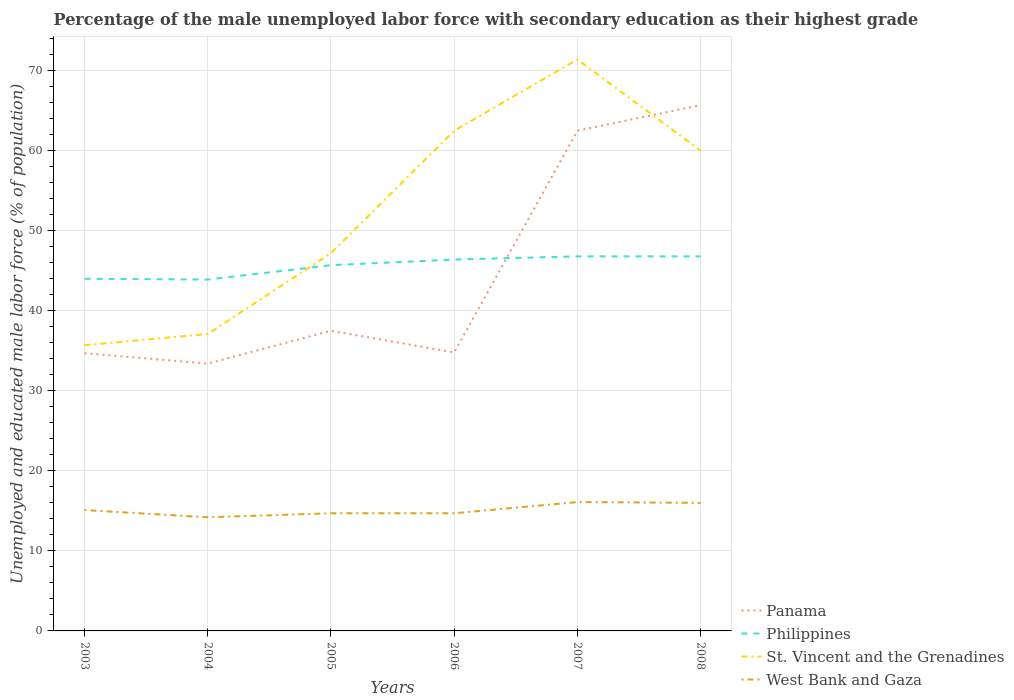Across all years, what is the maximum percentage of the unemployed male labor force with secondary education in West Bank and Gaza?
Keep it short and to the point. 14.2. In which year was the percentage of the unemployed male labor force with secondary education in Philippines maximum?
Offer a terse response. 2004. What is the total percentage of the unemployed male labor force with secondary education in Panama in the graph?
Provide a succinct answer. -29.1. What is the difference between the highest and the second highest percentage of the unemployed male labor force with secondary education in St. Vincent and the Grenadines?
Provide a succinct answer. 35.7. What is the difference between the highest and the lowest percentage of the unemployed male labor force with secondary education in West Bank and Gaza?
Provide a succinct answer. 2. Is the percentage of the unemployed male labor force with secondary education in St. Vincent and the Grenadines strictly greater than the percentage of the unemployed male labor force with secondary education in West Bank and Gaza over the years?
Your answer should be very brief. No. Are the values on the major ticks of Y-axis written in scientific E-notation?
Offer a terse response. No. Does the graph contain any zero values?
Ensure brevity in your answer.  No. Does the graph contain grids?
Your response must be concise. Yes. How many legend labels are there?
Ensure brevity in your answer.  4. How are the legend labels stacked?
Your response must be concise. Vertical. What is the title of the graph?
Offer a terse response. Percentage of the male unemployed labor force with secondary education as their highest grade. Does "Finland" appear as one of the legend labels in the graph?
Give a very brief answer. No. What is the label or title of the Y-axis?
Make the answer very short. Unemployed and educated male labor force (% of population). What is the Unemployed and educated male labor force (% of population) of Panama in 2003?
Your response must be concise. 34.7. What is the Unemployed and educated male labor force (% of population) of Philippines in 2003?
Offer a terse response. 44. What is the Unemployed and educated male labor force (% of population) of St. Vincent and the Grenadines in 2003?
Offer a very short reply. 35.7. What is the Unemployed and educated male labor force (% of population) of West Bank and Gaza in 2003?
Ensure brevity in your answer.  15.1. What is the Unemployed and educated male labor force (% of population) in Panama in 2004?
Make the answer very short. 33.4. What is the Unemployed and educated male labor force (% of population) in Philippines in 2004?
Keep it short and to the point. 43.9. What is the Unemployed and educated male labor force (% of population) of St. Vincent and the Grenadines in 2004?
Offer a terse response. 37.1. What is the Unemployed and educated male labor force (% of population) in West Bank and Gaza in 2004?
Your answer should be compact. 14.2. What is the Unemployed and educated male labor force (% of population) in Panama in 2005?
Keep it short and to the point. 37.5. What is the Unemployed and educated male labor force (% of population) of Philippines in 2005?
Offer a very short reply. 45.7. What is the Unemployed and educated male labor force (% of population) of St. Vincent and the Grenadines in 2005?
Offer a very short reply. 47.2. What is the Unemployed and educated male labor force (% of population) of West Bank and Gaza in 2005?
Your answer should be compact. 14.7. What is the Unemployed and educated male labor force (% of population) in Panama in 2006?
Make the answer very short. 34.8. What is the Unemployed and educated male labor force (% of population) in Philippines in 2006?
Your response must be concise. 46.4. What is the Unemployed and educated male labor force (% of population) of St. Vincent and the Grenadines in 2006?
Your answer should be compact. 62.5. What is the Unemployed and educated male labor force (% of population) in West Bank and Gaza in 2006?
Offer a terse response. 14.7. What is the Unemployed and educated male labor force (% of population) in Panama in 2007?
Keep it short and to the point. 62.5. What is the Unemployed and educated male labor force (% of population) in Philippines in 2007?
Give a very brief answer. 46.8. What is the Unemployed and educated male labor force (% of population) in St. Vincent and the Grenadines in 2007?
Keep it short and to the point. 71.4. What is the Unemployed and educated male labor force (% of population) in West Bank and Gaza in 2007?
Provide a short and direct response. 16.1. What is the Unemployed and educated male labor force (% of population) of Panama in 2008?
Give a very brief answer. 65.7. What is the Unemployed and educated male labor force (% of population) in Philippines in 2008?
Provide a short and direct response. 46.8. What is the Unemployed and educated male labor force (% of population) in St. Vincent and the Grenadines in 2008?
Offer a very short reply. 60. What is the Unemployed and educated male labor force (% of population) of West Bank and Gaza in 2008?
Make the answer very short. 16. Across all years, what is the maximum Unemployed and educated male labor force (% of population) in Panama?
Ensure brevity in your answer.  65.7. Across all years, what is the maximum Unemployed and educated male labor force (% of population) in Philippines?
Ensure brevity in your answer.  46.8. Across all years, what is the maximum Unemployed and educated male labor force (% of population) in St. Vincent and the Grenadines?
Provide a short and direct response. 71.4. Across all years, what is the maximum Unemployed and educated male labor force (% of population) of West Bank and Gaza?
Give a very brief answer. 16.1. Across all years, what is the minimum Unemployed and educated male labor force (% of population) in Panama?
Provide a succinct answer. 33.4. Across all years, what is the minimum Unemployed and educated male labor force (% of population) of Philippines?
Your response must be concise. 43.9. Across all years, what is the minimum Unemployed and educated male labor force (% of population) of St. Vincent and the Grenadines?
Give a very brief answer. 35.7. Across all years, what is the minimum Unemployed and educated male labor force (% of population) in West Bank and Gaza?
Provide a short and direct response. 14.2. What is the total Unemployed and educated male labor force (% of population) of Panama in the graph?
Make the answer very short. 268.6. What is the total Unemployed and educated male labor force (% of population) of Philippines in the graph?
Ensure brevity in your answer.  273.6. What is the total Unemployed and educated male labor force (% of population) of St. Vincent and the Grenadines in the graph?
Ensure brevity in your answer.  313.9. What is the total Unemployed and educated male labor force (% of population) of West Bank and Gaza in the graph?
Your answer should be very brief. 90.8. What is the difference between the Unemployed and educated male labor force (% of population) of Philippines in 2003 and that in 2004?
Ensure brevity in your answer.  0.1. What is the difference between the Unemployed and educated male labor force (% of population) of West Bank and Gaza in 2003 and that in 2004?
Provide a succinct answer. 0.9. What is the difference between the Unemployed and educated male labor force (% of population) in West Bank and Gaza in 2003 and that in 2005?
Your response must be concise. 0.4. What is the difference between the Unemployed and educated male labor force (% of population) of Panama in 2003 and that in 2006?
Keep it short and to the point. -0.1. What is the difference between the Unemployed and educated male labor force (% of population) in Philippines in 2003 and that in 2006?
Ensure brevity in your answer.  -2.4. What is the difference between the Unemployed and educated male labor force (% of population) of St. Vincent and the Grenadines in 2003 and that in 2006?
Your response must be concise. -26.8. What is the difference between the Unemployed and educated male labor force (% of population) of West Bank and Gaza in 2003 and that in 2006?
Ensure brevity in your answer.  0.4. What is the difference between the Unemployed and educated male labor force (% of population) of Panama in 2003 and that in 2007?
Make the answer very short. -27.8. What is the difference between the Unemployed and educated male labor force (% of population) in Philippines in 2003 and that in 2007?
Your answer should be compact. -2.8. What is the difference between the Unemployed and educated male labor force (% of population) in St. Vincent and the Grenadines in 2003 and that in 2007?
Your answer should be compact. -35.7. What is the difference between the Unemployed and educated male labor force (% of population) in Panama in 2003 and that in 2008?
Ensure brevity in your answer.  -31. What is the difference between the Unemployed and educated male labor force (% of population) in Philippines in 2003 and that in 2008?
Ensure brevity in your answer.  -2.8. What is the difference between the Unemployed and educated male labor force (% of population) of St. Vincent and the Grenadines in 2003 and that in 2008?
Give a very brief answer. -24.3. What is the difference between the Unemployed and educated male labor force (% of population) of West Bank and Gaza in 2003 and that in 2008?
Give a very brief answer. -0.9. What is the difference between the Unemployed and educated male labor force (% of population) in St. Vincent and the Grenadines in 2004 and that in 2005?
Provide a succinct answer. -10.1. What is the difference between the Unemployed and educated male labor force (% of population) in Panama in 2004 and that in 2006?
Offer a terse response. -1.4. What is the difference between the Unemployed and educated male labor force (% of population) in Philippines in 2004 and that in 2006?
Offer a very short reply. -2.5. What is the difference between the Unemployed and educated male labor force (% of population) of St. Vincent and the Grenadines in 2004 and that in 2006?
Provide a succinct answer. -25.4. What is the difference between the Unemployed and educated male labor force (% of population) in Panama in 2004 and that in 2007?
Your response must be concise. -29.1. What is the difference between the Unemployed and educated male labor force (% of population) of Philippines in 2004 and that in 2007?
Keep it short and to the point. -2.9. What is the difference between the Unemployed and educated male labor force (% of population) in St. Vincent and the Grenadines in 2004 and that in 2007?
Offer a very short reply. -34.3. What is the difference between the Unemployed and educated male labor force (% of population) in West Bank and Gaza in 2004 and that in 2007?
Provide a succinct answer. -1.9. What is the difference between the Unemployed and educated male labor force (% of population) in Panama in 2004 and that in 2008?
Your answer should be compact. -32.3. What is the difference between the Unemployed and educated male labor force (% of population) of Philippines in 2004 and that in 2008?
Keep it short and to the point. -2.9. What is the difference between the Unemployed and educated male labor force (% of population) in St. Vincent and the Grenadines in 2004 and that in 2008?
Your response must be concise. -22.9. What is the difference between the Unemployed and educated male labor force (% of population) in St. Vincent and the Grenadines in 2005 and that in 2006?
Your answer should be very brief. -15.3. What is the difference between the Unemployed and educated male labor force (% of population) in St. Vincent and the Grenadines in 2005 and that in 2007?
Make the answer very short. -24.2. What is the difference between the Unemployed and educated male labor force (% of population) of Panama in 2005 and that in 2008?
Give a very brief answer. -28.2. What is the difference between the Unemployed and educated male labor force (% of population) of Philippines in 2005 and that in 2008?
Keep it short and to the point. -1.1. What is the difference between the Unemployed and educated male labor force (% of population) in St. Vincent and the Grenadines in 2005 and that in 2008?
Offer a terse response. -12.8. What is the difference between the Unemployed and educated male labor force (% of population) of West Bank and Gaza in 2005 and that in 2008?
Keep it short and to the point. -1.3. What is the difference between the Unemployed and educated male labor force (% of population) in Panama in 2006 and that in 2007?
Offer a terse response. -27.7. What is the difference between the Unemployed and educated male labor force (% of population) of Philippines in 2006 and that in 2007?
Ensure brevity in your answer.  -0.4. What is the difference between the Unemployed and educated male labor force (% of population) in West Bank and Gaza in 2006 and that in 2007?
Give a very brief answer. -1.4. What is the difference between the Unemployed and educated male labor force (% of population) in Panama in 2006 and that in 2008?
Your response must be concise. -30.9. What is the difference between the Unemployed and educated male labor force (% of population) of Philippines in 2006 and that in 2008?
Make the answer very short. -0.4. What is the difference between the Unemployed and educated male labor force (% of population) of West Bank and Gaza in 2006 and that in 2008?
Give a very brief answer. -1.3. What is the difference between the Unemployed and educated male labor force (% of population) of Philippines in 2007 and that in 2008?
Keep it short and to the point. 0. What is the difference between the Unemployed and educated male labor force (% of population) in St. Vincent and the Grenadines in 2007 and that in 2008?
Provide a short and direct response. 11.4. What is the difference between the Unemployed and educated male labor force (% of population) of Panama in 2003 and the Unemployed and educated male labor force (% of population) of St. Vincent and the Grenadines in 2004?
Your response must be concise. -2.4. What is the difference between the Unemployed and educated male labor force (% of population) in Panama in 2003 and the Unemployed and educated male labor force (% of population) in West Bank and Gaza in 2004?
Ensure brevity in your answer.  20.5. What is the difference between the Unemployed and educated male labor force (% of population) in Philippines in 2003 and the Unemployed and educated male labor force (% of population) in St. Vincent and the Grenadines in 2004?
Make the answer very short. 6.9. What is the difference between the Unemployed and educated male labor force (% of population) in Philippines in 2003 and the Unemployed and educated male labor force (% of population) in West Bank and Gaza in 2004?
Offer a very short reply. 29.8. What is the difference between the Unemployed and educated male labor force (% of population) of St. Vincent and the Grenadines in 2003 and the Unemployed and educated male labor force (% of population) of West Bank and Gaza in 2004?
Ensure brevity in your answer.  21.5. What is the difference between the Unemployed and educated male labor force (% of population) of Panama in 2003 and the Unemployed and educated male labor force (% of population) of Philippines in 2005?
Offer a terse response. -11. What is the difference between the Unemployed and educated male labor force (% of population) in Philippines in 2003 and the Unemployed and educated male labor force (% of population) in St. Vincent and the Grenadines in 2005?
Keep it short and to the point. -3.2. What is the difference between the Unemployed and educated male labor force (% of population) in Philippines in 2003 and the Unemployed and educated male labor force (% of population) in West Bank and Gaza in 2005?
Offer a terse response. 29.3. What is the difference between the Unemployed and educated male labor force (% of population) in Panama in 2003 and the Unemployed and educated male labor force (% of population) in Philippines in 2006?
Provide a short and direct response. -11.7. What is the difference between the Unemployed and educated male labor force (% of population) in Panama in 2003 and the Unemployed and educated male labor force (% of population) in St. Vincent and the Grenadines in 2006?
Your answer should be compact. -27.8. What is the difference between the Unemployed and educated male labor force (% of population) of Panama in 2003 and the Unemployed and educated male labor force (% of population) of West Bank and Gaza in 2006?
Keep it short and to the point. 20. What is the difference between the Unemployed and educated male labor force (% of population) in Philippines in 2003 and the Unemployed and educated male labor force (% of population) in St. Vincent and the Grenadines in 2006?
Provide a succinct answer. -18.5. What is the difference between the Unemployed and educated male labor force (% of population) of Philippines in 2003 and the Unemployed and educated male labor force (% of population) of West Bank and Gaza in 2006?
Your response must be concise. 29.3. What is the difference between the Unemployed and educated male labor force (% of population) in Panama in 2003 and the Unemployed and educated male labor force (% of population) in St. Vincent and the Grenadines in 2007?
Make the answer very short. -36.7. What is the difference between the Unemployed and educated male labor force (% of population) of Philippines in 2003 and the Unemployed and educated male labor force (% of population) of St. Vincent and the Grenadines in 2007?
Your response must be concise. -27.4. What is the difference between the Unemployed and educated male labor force (% of population) in Philippines in 2003 and the Unemployed and educated male labor force (% of population) in West Bank and Gaza in 2007?
Keep it short and to the point. 27.9. What is the difference between the Unemployed and educated male labor force (% of population) of St. Vincent and the Grenadines in 2003 and the Unemployed and educated male labor force (% of population) of West Bank and Gaza in 2007?
Your answer should be compact. 19.6. What is the difference between the Unemployed and educated male labor force (% of population) of Panama in 2003 and the Unemployed and educated male labor force (% of population) of St. Vincent and the Grenadines in 2008?
Give a very brief answer. -25.3. What is the difference between the Unemployed and educated male labor force (% of population) in Philippines in 2003 and the Unemployed and educated male labor force (% of population) in West Bank and Gaza in 2008?
Ensure brevity in your answer.  28. What is the difference between the Unemployed and educated male labor force (% of population) of Panama in 2004 and the Unemployed and educated male labor force (% of population) of St. Vincent and the Grenadines in 2005?
Offer a terse response. -13.8. What is the difference between the Unemployed and educated male labor force (% of population) of Panama in 2004 and the Unemployed and educated male labor force (% of population) of West Bank and Gaza in 2005?
Give a very brief answer. 18.7. What is the difference between the Unemployed and educated male labor force (% of population) of Philippines in 2004 and the Unemployed and educated male labor force (% of population) of St. Vincent and the Grenadines in 2005?
Offer a terse response. -3.3. What is the difference between the Unemployed and educated male labor force (% of population) in Philippines in 2004 and the Unemployed and educated male labor force (% of population) in West Bank and Gaza in 2005?
Provide a succinct answer. 29.2. What is the difference between the Unemployed and educated male labor force (% of population) of St. Vincent and the Grenadines in 2004 and the Unemployed and educated male labor force (% of population) of West Bank and Gaza in 2005?
Ensure brevity in your answer.  22.4. What is the difference between the Unemployed and educated male labor force (% of population) in Panama in 2004 and the Unemployed and educated male labor force (% of population) in St. Vincent and the Grenadines in 2006?
Ensure brevity in your answer.  -29.1. What is the difference between the Unemployed and educated male labor force (% of population) of Philippines in 2004 and the Unemployed and educated male labor force (% of population) of St. Vincent and the Grenadines in 2006?
Give a very brief answer. -18.6. What is the difference between the Unemployed and educated male labor force (% of population) in Philippines in 2004 and the Unemployed and educated male labor force (% of population) in West Bank and Gaza in 2006?
Keep it short and to the point. 29.2. What is the difference between the Unemployed and educated male labor force (% of population) of St. Vincent and the Grenadines in 2004 and the Unemployed and educated male labor force (% of population) of West Bank and Gaza in 2006?
Give a very brief answer. 22.4. What is the difference between the Unemployed and educated male labor force (% of population) of Panama in 2004 and the Unemployed and educated male labor force (% of population) of Philippines in 2007?
Provide a short and direct response. -13.4. What is the difference between the Unemployed and educated male labor force (% of population) of Panama in 2004 and the Unemployed and educated male labor force (% of population) of St. Vincent and the Grenadines in 2007?
Offer a terse response. -38. What is the difference between the Unemployed and educated male labor force (% of population) of Panama in 2004 and the Unemployed and educated male labor force (% of population) of West Bank and Gaza in 2007?
Offer a very short reply. 17.3. What is the difference between the Unemployed and educated male labor force (% of population) in Philippines in 2004 and the Unemployed and educated male labor force (% of population) in St. Vincent and the Grenadines in 2007?
Offer a terse response. -27.5. What is the difference between the Unemployed and educated male labor force (% of population) of Philippines in 2004 and the Unemployed and educated male labor force (% of population) of West Bank and Gaza in 2007?
Make the answer very short. 27.8. What is the difference between the Unemployed and educated male labor force (% of population) of Panama in 2004 and the Unemployed and educated male labor force (% of population) of St. Vincent and the Grenadines in 2008?
Your answer should be compact. -26.6. What is the difference between the Unemployed and educated male labor force (% of population) in Panama in 2004 and the Unemployed and educated male labor force (% of population) in West Bank and Gaza in 2008?
Provide a short and direct response. 17.4. What is the difference between the Unemployed and educated male labor force (% of population) of Philippines in 2004 and the Unemployed and educated male labor force (% of population) of St. Vincent and the Grenadines in 2008?
Offer a very short reply. -16.1. What is the difference between the Unemployed and educated male labor force (% of population) of Philippines in 2004 and the Unemployed and educated male labor force (% of population) of West Bank and Gaza in 2008?
Your answer should be very brief. 27.9. What is the difference between the Unemployed and educated male labor force (% of population) in St. Vincent and the Grenadines in 2004 and the Unemployed and educated male labor force (% of population) in West Bank and Gaza in 2008?
Offer a terse response. 21.1. What is the difference between the Unemployed and educated male labor force (% of population) of Panama in 2005 and the Unemployed and educated male labor force (% of population) of Philippines in 2006?
Keep it short and to the point. -8.9. What is the difference between the Unemployed and educated male labor force (% of population) in Panama in 2005 and the Unemployed and educated male labor force (% of population) in St. Vincent and the Grenadines in 2006?
Your answer should be very brief. -25. What is the difference between the Unemployed and educated male labor force (% of population) of Panama in 2005 and the Unemployed and educated male labor force (% of population) of West Bank and Gaza in 2006?
Offer a very short reply. 22.8. What is the difference between the Unemployed and educated male labor force (% of population) of Philippines in 2005 and the Unemployed and educated male labor force (% of population) of St. Vincent and the Grenadines in 2006?
Offer a terse response. -16.8. What is the difference between the Unemployed and educated male labor force (% of population) of St. Vincent and the Grenadines in 2005 and the Unemployed and educated male labor force (% of population) of West Bank and Gaza in 2006?
Provide a succinct answer. 32.5. What is the difference between the Unemployed and educated male labor force (% of population) in Panama in 2005 and the Unemployed and educated male labor force (% of population) in St. Vincent and the Grenadines in 2007?
Offer a terse response. -33.9. What is the difference between the Unemployed and educated male labor force (% of population) in Panama in 2005 and the Unemployed and educated male labor force (% of population) in West Bank and Gaza in 2007?
Keep it short and to the point. 21.4. What is the difference between the Unemployed and educated male labor force (% of population) in Philippines in 2005 and the Unemployed and educated male labor force (% of population) in St. Vincent and the Grenadines in 2007?
Ensure brevity in your answer.  -25.7. What is the difference between the Unemployed and educated male labor force (% of population) in Philippines in 2005 and the Unemployed and educated male labor force (% of population) in West Bank and Gaza in 2007?
Your answer should be very brief. 29.6. What is the difference between the Unemployed and educated male labor force (% of population) in St. Vincent and the Grenadines in 2005 and the Unemployed and educated male labor force (% of population) in West Bank and Gaza in 2007?
Make the answer very short. 31.1. What is the difference between the Unemployed and educated male labor force (% of population) of Panama in 2005 and the Unemployed and educated male labor force (% of population) of St. Vincent and the Grenadines in 2008?
Offer a terse response. -22.5. What is the difference between the Unemployed and educated male labor force (% of population) in Philippines in 2005 and the Unemployed and educated male labor force (% of population) in St. Vincent and the Grenadines in 2008?
Offer a very short reply. -14.3. What is the difference between the Unemployed and educated male labor force (% of population) of Philippines in 2005 and the Unemployed and educated male labor force (% of population) of West Bank and Gaza in 2008?
Keep it short and to the point. 29.7. What is the difference between the Unemployed and educated male labor force (% of population) in St. Vincent and the Grenadines in 2005 and the Unemployed and educated male labor force (% of population) in West Bank and Gaza in 2008?
Keep it short and to the point. 31.2. What is the difference between the Unemployed and educated male labor force (% of population) of Panama in 2006 and the Unemployed and educated male labor force (% of population) of Philippines in 2007?
Make the answer very short. -12. What is the difference between the Unemployed and educated male labor force (% of population) of Panama in 2006 and the Unemployed and educated male labor force (% of population) of St. Vincent and the Grenadines in 2007?
Ensure brevity in your answer.  -36.6. What is the difference between the Unemployed and educated male labor force (% of population) of Panama in 2006 and the Unemployed and educated male labor force (% of population) of West Bank and Gaza in 2007?
Make the answer very short. 18.7. What is the difference between the Unemployed and educated male labor force (% of population) of Philippines in 2006 and the Unemployed and educated male labor force (% of population) of West Bank and Gaza in 2007?
Ensure brevity in your answer.  30.3. What is the difference between the Unemployed and educated male labor force (% of population) in St. Vincent and the Grenadines in 2006 and the Unemployed and educated male labor force (% of population) in West Bank and Gaza in 2007?
Keep it short and to the point. 46.4. What is the difference between the Unemployed and educated male labor force (% of population) of Panama in 2006 and the Unemployed and educated male labor force (% of population) of St. Vincent and the Grenadines in 2008?
Provide a succinct answer. -25.2. What is the difference between the Unemployed and educated male labor force (% of population) of Philippines in 2006 and the Unemployed and educated male labor force (% of population) of West Bank and Gaza in 2008?
Keep it short and to the point. 30.4. What is the difference between the Unemployed and educated male labor force (% of population) of St. Vincent and the Grenadines in 2006 and the Unemployed and educated male labor force (% of population) of West Bank and Gaza in 2008?
Your response must be concise. 46.5. What is the difference between the Unemployed and educated male labor force (% of population) of Panama in 2007 and the Unemployed and educated male labor force (% of population) of Philippines in 2008?
Offer a terse response. 15.7. What is the difference between the Unemployed and educated male labor force (% of population) of Panama in 2007 and the Unemployed and educated male labor force (% of population) of West Bank and Gaza in 2008?
Ensure brevity in your answer.  46.5. What is the difference between the Unemployed and educated male labor force (% of population) in Philippines in 2007 and the Unemployed and educated male labor force (% of population) in West Bank and Gaza in 2008?
Offer a terse response. 30.8. What is the difference between the Unemployed and educated male labor force (% of population) in St. Vincent and the Grenadines in 2007 and the Unemployed and educated male labor force (% of population) in West Bank and Gaza in 2008?
Your answer should be very brief. 55.4. What is the average Unemployed and educated male labor force (% of population) of Panama per year?
Provide a succinct answer. 44.77. What is the average Unemployed and educated male labor force (% of population) in Philippines per year?
Your answer should be very brief. 45.6. What is the average Unemployed and educated male labor force (% of population) in St. Vincent and the Grenadines per year?
Make the answer very short. 52.32. What is the average Unemployed and educated male labor force (% of population) in West Bank and Gaza per year?
Your answer should be very brief. 15.13. In the year 2003, what is the difference between the Unemployed and educated male labor force (% of population) in Panama and Unemployed and educated male labor force (% of population) in West Bank and Gaza?
Offer a very short reply. 19.6. In the year 2003, what is the difference between the Unemployed and educated male labor force (% of population) in Philippines and Unemployed and educated male labor force (% of population) in West Bank and Gaza?
Your answer should be very brief. 28.9. In the year 2003, what is the difference between the Unemployed and educated male labor force (% of population) of St. Vincent and the Grenadines and Unemployed and educated male labor force (% of population) of West Bank and Gaza?
Offer a very short reply. 20.6. In the year 2004, what is the difference between the Unemployed and educated male labor force (% of population) of Panama and Unemployed and educated male labor force (% of population) of Philippines?
Offer a very short reply. -10.5. In the year 2004, what is the difference between the Unemployed and educated male labor force (% of population) in Panama and Unemployed and educated male labor force (% of population) in St. Vincent and the Grenadines?
Ensure brevity in your answer.  -3.7. In the year 2004, what is the difference between the Unemployed and educated male labor force (% of population) of Philippines and Unemployed and educated male labor force (% of population) of St. Vincent and the Grenadines?
Provide a succinct answer. 6.8. In the year 2004, what is the difference between the Unemployed and educated male labor force (% of population) of Philippines and Unemployed and educated male labor force (% of population) of West Bank and Gaza?
Offer a very short reply. 29.7. In the year 2004, what is the difference between the Unemployed and educated male labor force (% of population) in St. Vincent and the Grenadines and Unemployed and educated male labor force (% of population) in West Bank and Gaza?
Give a very brief answer. 22.9. In the year 2005, what is the difference between the Unemployed and educated male labor force (% of population) of Panama and Unemployed and educated male labor force (% of population) of Philippines?
Your answer should be very brief. -8.2. In the year 2005, what is the difference between the Unemployed and educated male labor force (% of population) in Panama and Unemployed and educated male labor force (% of population) in St. Vincent and the Grenadines?
Make the answer very short. -9.7. In the year 2005, what is the difference between the Unemployed and educated male labor force (% of population) of Panama and Unemployed and educated male labor force (% of population) of West Bank and Gaza?
Offer a terse response. 22.8. In the year 2005, what is the difference between the Unemployed and educated male labor force (% of population) of St. Vincent and the Grenadines and Unemployed and educated male labor force (% of population) of West Bank and Gaza?
Offer a very short reply. 32.5. In the year 2006, what is the difference between the Unemployed and educated male labor force (% of population) of Panama and Unemployed and educated male labor force (% of population) of St. Vincent and the Grenadines?
Ensure brevity in your answer.  -27.7. In the year 2006, what is the difference between the Unemployed and educated male labor force (% of population) of Panama and Unemployed and educated male labor force (% of population) of West Bank and Gaza?
Provide a succinct answer. 20.1. In the year 2006, what is the difference between the Unemployed and educated male labor force (% of population) of Philippines and Unemployed and educated male labor force (% of population) of St. Vincent and the Grenadines?
Your answer should be very brief. -16.1. In the year 2006, what is the difference between the Unemployed and educated male labor force (% of population) of Philippines and Unemployed and educated male labor force (% of population) of West Bank and Gaza?
Provide a succinct answer. 31.7. In the year 2006, what is the difference between the Unemployed and educated male labor force (% of population) in St. Vincent and the Grenadines and Unemployed and educated male labor force (% of population) in West Bank and Gaza?
Your response must be concise. 47.8. In the year 2007, what is the difference between the Unemployed and educated male labor force (% of population) in Panama and Unemployed and educated male labor force (% of population) in Philippines?
Your response must be concise. 15.7. In the year 2007, what is the difference between the Unemployed and educated male labor force (% of population) of Panama and Unemployed and educated male labor force (% of population) of West Bank and Gaza?
Make the answer very short. 46.4. In the year 2007, what is the difference between the Unemployed and educated male labor force (% of population) in Philippines and Unemployed and educated male labor force (% of population) in St. Vincent and the Grenadines?
Your answer should be very brief. -24.6. In the year 2007, what is the difference between the Unemployed and educated male labor force (% of population) in Philippines and Unemployed and educated male labor force (% of population) in West Bank and Gaza?
Offer a very short reply. 30.7. In the year 2007, what is the difference between the Unemployed and educated male labor force (% of population) in St. Vincent and the Grenadines and Unemployed and educated male labor force (% of population) in West Bank and Gaza?
Provide a short and direct response. 55.3. In the year 2008, what is the difference between the Unemployed and educated male labor force (% of population) in Panama and Unemployed and educated male labor force (% of population) in Philippines?
Provide a short and direct response. 18.9. In the year 2008, what is the difference between the Unemployed and educated male labor force (% of population) of Panama and Unemployed and educated male labor force (% of population) of West Bank and Gaza?
Your answer should be very brief. 49.7. In the year 2008, what is the difference between the Unemployed and educated male labor force (% of population) of Philippines and Unemployed and educated male labor force (% of population) of West Bank and Gaza?
Your answer should be compact. 30.8. What is the ratio of the Unemployed and educated male labor force (% of population) in Panama in 2003 to that in 2004?
Keep it short and to the point. 1.04. What is the ratio of the Unemployed and educated male labor force (% of population) in Philippines in 2003 to that in 2004?
Offer a very short reply. 1. What is the ratio of the Unemployed and educated male labor force (% of population) in St. Vincent and the Grenadines in 2003 to that in 2004?
Offer a very short reply. 0.96. What is the ratio of the Unemployed and educated male labor force (% of population) in West Bank and Gaza in 2003 to that in 2004?
Ensure brevity in your answer.  1.06. What is the ratio of the Unemployed and educated male labor force (% of population) of Panama in 2003 to that in 2005?
Ensure brevity in your answer.  0.93. What is the ratio of the Unemployed and educated male labor force (% of population) in Philippines in 2003 to that in 2005?
Ensure brevity in your answer.  0.96. What is the ratio of the Unemployed and educated male labor force (% of population) in St. Vincent and the Grenadines in 2003 to that in 2005?
Provide a succinct answer. 0.76. What is the ratio of the Unemployed and educated male labor force (% of population) in West Bank and Gaza in 2003 to that in 2005?
Provide a short and direct response. 1.03. What is the ratio of the Unemployed and educated male labor force (% of population) of Philippines in 2003 to that in 2006?
Offer a terse response. 0.95. What is the ratio of the Unemployed and educated male labor force (% of population) of St. Vincent and the Grenadines in 2003 to that in 2006?
Offer a terse response. 0.57. What is the ratio of the Unemployed and educated male labor force (% of population) of West Bank and Gaza in 2003 to that in 2006?
Your response must be concise. 1.03. What is the ratio of the Unemployed and educated male labor force (% of population) in Panama in 2003 to that in 2007?
Keep it short and to the point. 0.56. What is the ratio of the Unemployed and educated male labor force (% of population) of Philippines in 2003 to that in 2007?
Give a very brief answer. 0.94. What is the ratio of the Unemployed and educated male labor force (% of population) of St. Vincent and the Grenadines in 2003 to that in 2007?
Provide a succinct answer. 0.5. What is the ratio of the Unemployed and educated male labor force (% of population) of West Bank and Gaza in 2003 to that in 2007?
Make the answer very short. 0.94. What is the ratio of the Unemployed and educated male labor force (% of population) in Panama in 2003 to that in 2008?
Offer a very short reply. 0.53. What is the ratio of the Unemployed and educated male labor force (% of population) in Philippines in 2003 to that in 2008?
Give a very brief answer. 0.94. What is the ratio of the Unemployed and educated male labor force (% of population) of St. Vincent and the Grenadines in 2003 to that in 2008?
Provide a succinct answer. 0.59. What is the ratio of the Unemployed and educated male labor force (% of population) of West Bank and Gaza in 2003 to that in 2008?
Your answer should be compact. 0.94. What is the ratio of the Unemployed and educated male labor force (% of population) in Panama in 2004 to that in 2005?
Offer a terse response. 0.89. What is the ratio of the Unemployed and educated male labor force (% of population) in Philippines in 2004 to that in 2005?
Give a very brief answer. 0.96. What is the ratio of the Unemployed and educated male labor force (% of population) of St. Vincent and the Grenadines in 2004 to that in 2005?
Offer a terse response. 0.79. What is the ratio of the Unemployed and educated male labor force (% of population) of West Bank and Gaza in 2004 to that in 2005?
Ensure brevity in your answer.  0.97. What is the ratio of the Unemployed and educated male labor force (% of population) of Panama in 2004 to that in 2006?
Your answer should be very brief. 0.96. What is the ratio of the Unemployed and educated male labor force (% of population) of Philippines in 2004 to that in 2006?
Provide a short and direct response. 0.95. What is the ratio of the Unemployed and educated male labor force (% of population) in St. Vincent and the Grenadines in 2004 to that in 2006?
Provide a short and direct response. 0.59. What is the ratio of the Unemployed and educated male labor force (% of population) in West Bank and Gaza in 2004 to that in 2006?
Keep it short and to the point. 0.97. What is the ratio of the Unemployed and educated male labor force (% of population) of Panama in 2004 to that in 2007?
Ensure brevity in your answer.  0.53. What is the ratio of the Unemployed and educated male labor force (% of population) in Philippines in 2004 to that in 2007?
Your response must be concise. 0.94. What is the ratio of the Unemployed and educated male labor force (% of population) in St. Vincent and the Grenadines in 2004 to that in 2007?
Your answer should be compact. 0.52. What is the ratio of the Unemployed and educated male labor force (% of population) of West Bank and Gaza in 2004 to that in 2007?
Offer a terse response. 0.88. What is the ratio of the Unemployed and educated male labor force (% of population) of Panama in 2004 to that in 2008?
Provide a succinct answer. 0.51. What is the ratio of the Unemployed and educated male labor force (% of population) in Philippines in 2004 to that in 2008?
Your answer should be compact. 0.94. What is the ratio of the Unemployed and educated male labor force (% of population) of St. Vincent and the Grenadines in 2004 to that in 2008?
Your answer should be compact. 0.62. What is the ratio of the Unemployed and educated male labor force (% of population) of West Bank and Gaza in 2004 to that in 2008?
Keep it short and to the point. 0.89. What is the ratio of the Unemployed and educated male labor force (% of population) in Panama in 2005 to that in 2006?
Your answer should be very brief. 1.08. What is the ratio of the Unemployed and educated male labor force (% of population) in Philippines in 2005 to that in 2006?
Make the answer very short. 0.98. What is the ratio of the Unemployed and educated male labor force (% of population) of St. Vincent and the Grenadines in 2005 to that in 2006?
Keep it short and to the point. 0.76. What is the ratio of the Unemployed and educated male labor force (% of population) of Philippines in 2005 to that in 2007?
Offer a terse response. 0.98. What is the ratio of the Unemployed and educated male labor force (% of population) of St. Vincent and the Grenadines in 2005 to that in 2007?
Ensure brevity in your answer.  0.66. What is the ratio of the Unemployed and educated male labor force (% of population) in Panama in 2005 to that in 2008?
Provide a short and direct response. 0.57. What is the ratio of the Unemployed and educated male labor force (% of population) of Philippines in 2005 to that in 2008?
Your answer should be compact. 0.98. What is the ratio of the Unemployed and educated male labor force (% of population) of St. Vincent and the Grenadines in 2005 to that in 2008?
Ensure brevity in your answer.  0.79. What is the ratio of the Unemployed and educated male labor force (% of population) in West Bank and Gaza in 2005 to that in 2008?
Provide a succinct answer. 0.92. What is the ratio of the Unemployed and educated male labor force (% of population) in Panama in 2006 to that in 2007?
Offer a terse response. 0.56. What is the ratio of the Unemployed and educated male labor force (% of population) in Philippines in 2006 to that in 2007?
Provide a succinct answer. 0.99. What is the ratio of the Unemployed and educated male labor force (% of population) of St. Vincent and the Grenadines in 2006 to that in 2007?
Your answer should be very brief. 0.88. What is the ratio of the Unemployed and educated male labor force (% of population) in West Bank and Gaza in 2006 to that in 2007?
Offer a very short reply. 0.91. What is the ratio of the Unemployed and educated male labor force (% of population) of Panama in 2006 to that in 2008?
Offer a very short reply. 0.53. What is the ratio of the Unemployed and educated male labor force (% of population) in Philippines in 2006 to that in 2008?
Give a very brief answer. 0.99. What is the ratio of the Unemployed and educated male labor force (% of population) of St. Vincent and the Grenadines in 2006 to that in 2008?
Your answer should be compact. 1.04. What is the ratio of the Unemployed and educated male labor force (% of population) of West Bank and Gaza in 2006 to that in 2008?
Provide a short and direct response. 0.92. What is the ratio of the Unemployed and educated male labor force (% of population) of Panama in 2007 to that in 2008?
Your response must be concise. 0.95. What is the ratio of the Unemployed and educated male labor force (% of population) in Philippines in 2007 to that in 2008?
Give a very brief answer. 1. What is the ratio of the Unemployed and educated male labor force (% of population) of St. Vincent and the Grenadines in 2007 to that in 2008?
Your answer should be compact. 1.19. What is the difference between the highest and the second highest Unemployed and educated male labor force (% of population) in Panama?
Make the answer very short. 3.2. What is the difference between the highest and the lowest Unemployed and educated male labor force (% of population) in Panama?
Your response must be concise. 32.3. What is the difference between the highest and the lowest Unemployed and educated male labor force (% of population) of Philippines?
Ensure brevity in your answer.  2.9. What is the difference between the highest and the lowest Unemployed and educated male labor force (% of population) in St. Vincent and the Grenadines?
Your response must be concise. 35.7. What is the difference between the highest and the lowest Unemployed and educated male labor force (% of population) in West Bank and Gaza?
Provide a succinct answer. 1.9. 